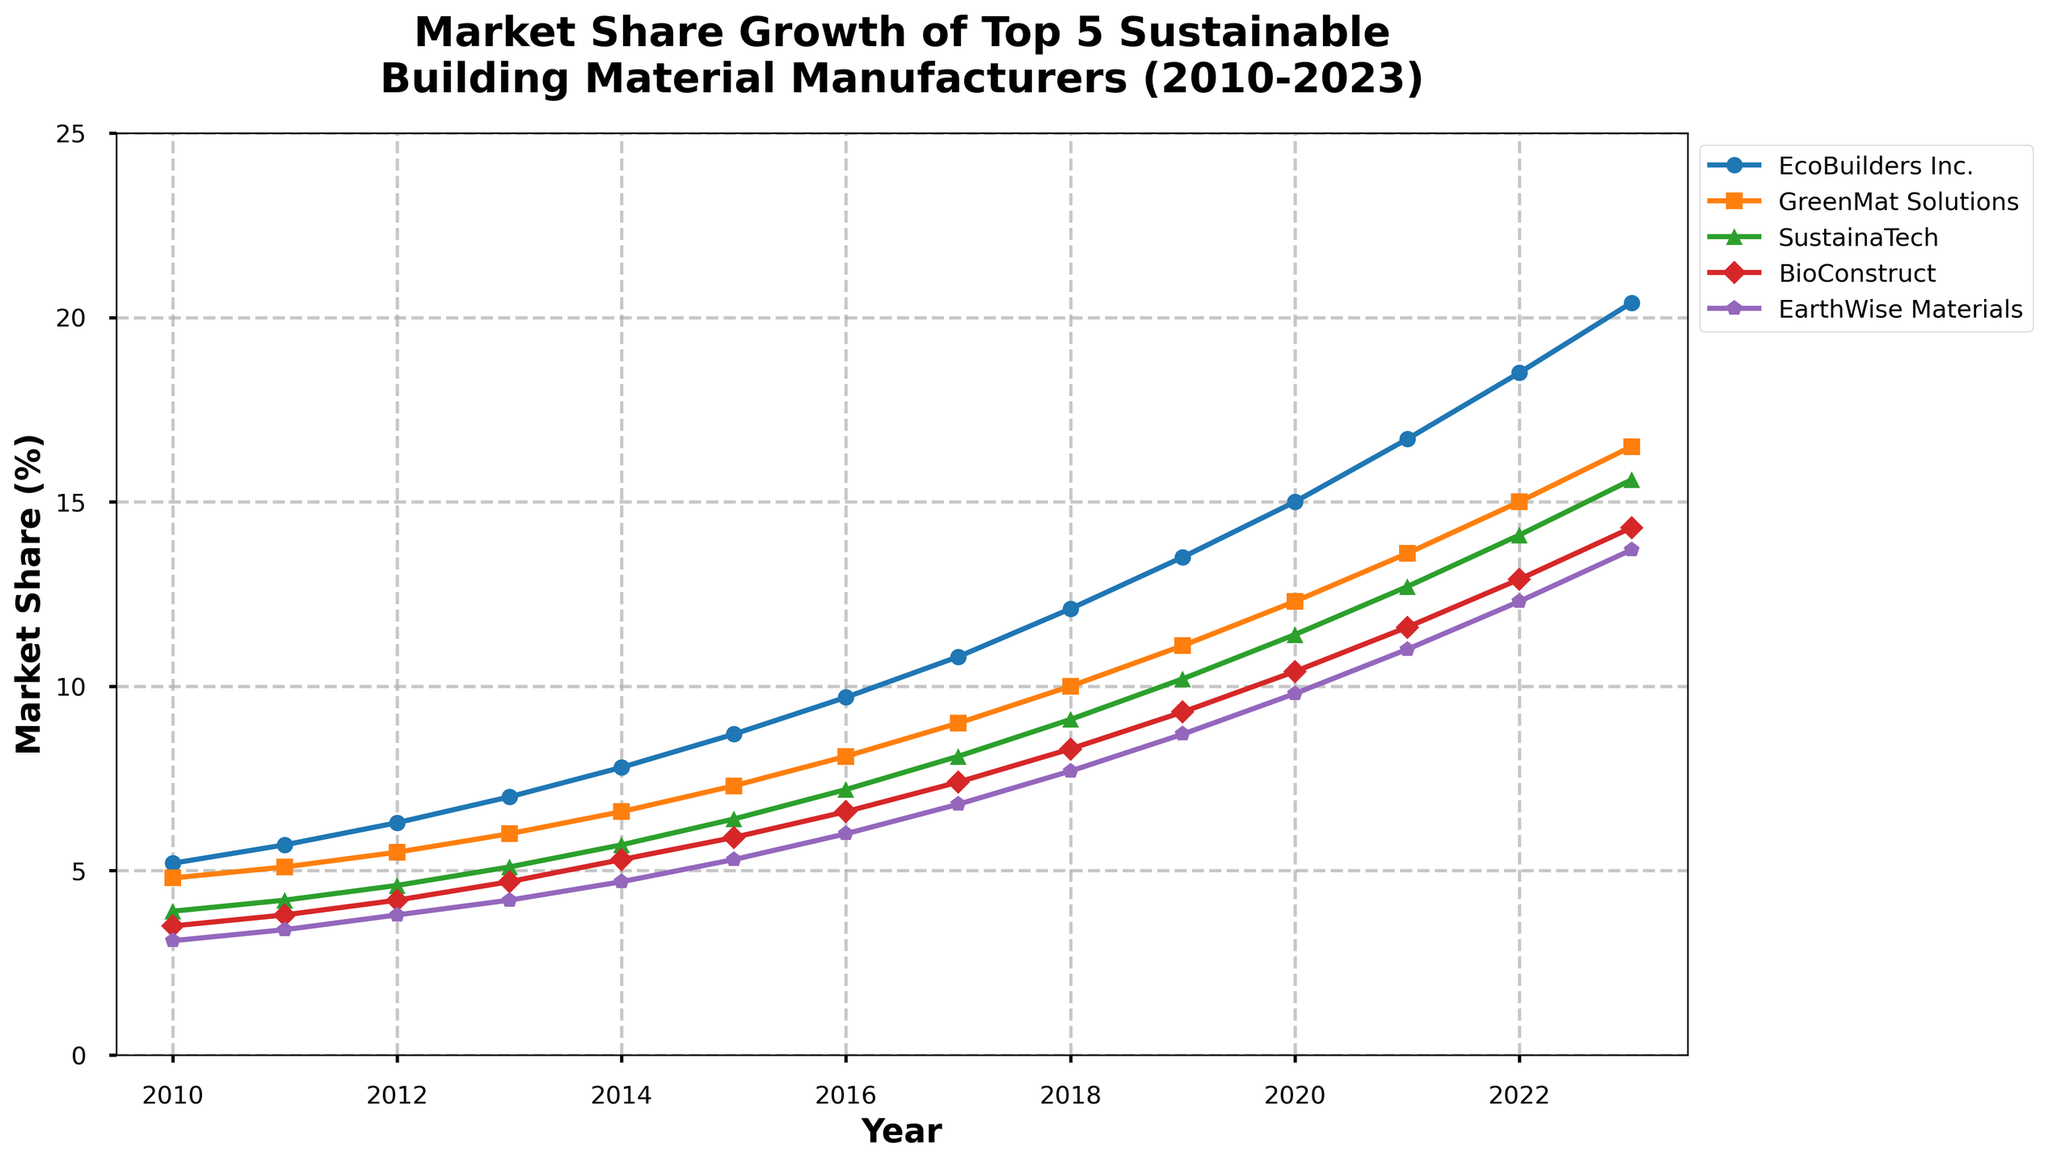What is the market share of EarthWise Materials in 2015? To find the market share of EarthWise Materials in 2015, look at the value on the EarthWise Materials line (purple color) corresponding to the 2015 tick on the x-axis.
Answer: 5.3% Which company had the highest market share in 2023? To determine which company had the highest market share in 2023, look at the market share values of all companies at the 2023 tick on the x-axis and identify the highest value.
Answer: EcoBuilders Inc By how much did the market share for BioConstruct increase from 2016 to 2023? Look at the BioConstruct market share values at the 2016 and 2023 ticks on the x-axis (6.6% and 14.3%, respectively). Subtract the 2016 value from the 2023 value. Calculation: 14.3 - 6.6 = 7.7
Answer: 7.7% Between 2018 and 2023, which company experienced the smallest increase in market share? Calculate the market share increase for each company between 2018 and 2023 by subtracting the 2018 values from the 2023 values. Compare the increments: 
EcoBuilders Inc.: 20.4 - 12.1 = 8.3 
GreenMat Solutions: 16.5 - 10.0 = 6.5 
SustainaTech: 15.6 - 9.1 = 6.5 
BioConstruct: 14.3 - 8.3 = 6.0 
EarthWise Materials: 13.7 - 7.7 = 6.0
The smallest increases are for SustainaTech and BioConstruct.
Answer: BioConstruct and SustainaTech In which year did GreenMat Solutions first achieve a market share greater than 10%? To find when GreenMat Solutions first surpassed 10%, look at the plotted line for GreenMat Solutions (orange color) and find the first year where the value crosses 10% on the y-axis. This happens in 2018.
Answer: 2018 From 2010 to 2023, which company had the most consistent growth rate? To identify the company with the most consistent growth, observe the smoothness and steepness of each line. Comparatively, EcoBuilders Inc. (blue line) shows a consistent and steady incline. Other companies have more variable slopes.
Answer: EcoBuilders Inc How did the market share of SustainaTech change from 2010 to 2023? Look at the SustainaTech line (green color) and compare the values at 2010 (3.9%) and 2023 (15.6%). Calculate the difference: 15.6% - 3.9% = 11.7%.
Answer: Increased by 11.7% What is the average market share of GreenMat Solutions from 2010 to 2015? Sum the market share values of GreenMat Solutions (2010: 4.8%, 2011: 5.1%, 2012: 5.5%, 2013: 6.0%, 2014: 6.6%, 2015: 7.3%) and divide by the number of years (6). Calculation: (4.8 + 5.1 + 5.5 + 6.0 + 6.6 + 7.3) / 6 = 5.88%.
Answer: 5.88% Which company’s market share exceeded 10% first? Identify which company's line first crosses the 10% mark on the y-axis. EcoBuilders Inc.’s line crosses 10% between 2016 and 2017, before any other company's line reaches this mark.
Answer: EcoBuilders Inc Which company's market share had the sharpest increase between any two consecutive years? Observe the steepness of the lines between consecutive years and identify the largest single-year increment by eye. EcoBuilders Inc.’s rise from 13.5% in 2019 to 15.0% in 2020 shows a sharp increase of 1.5 percentage points.
Answer: EcoBuilders Inc 